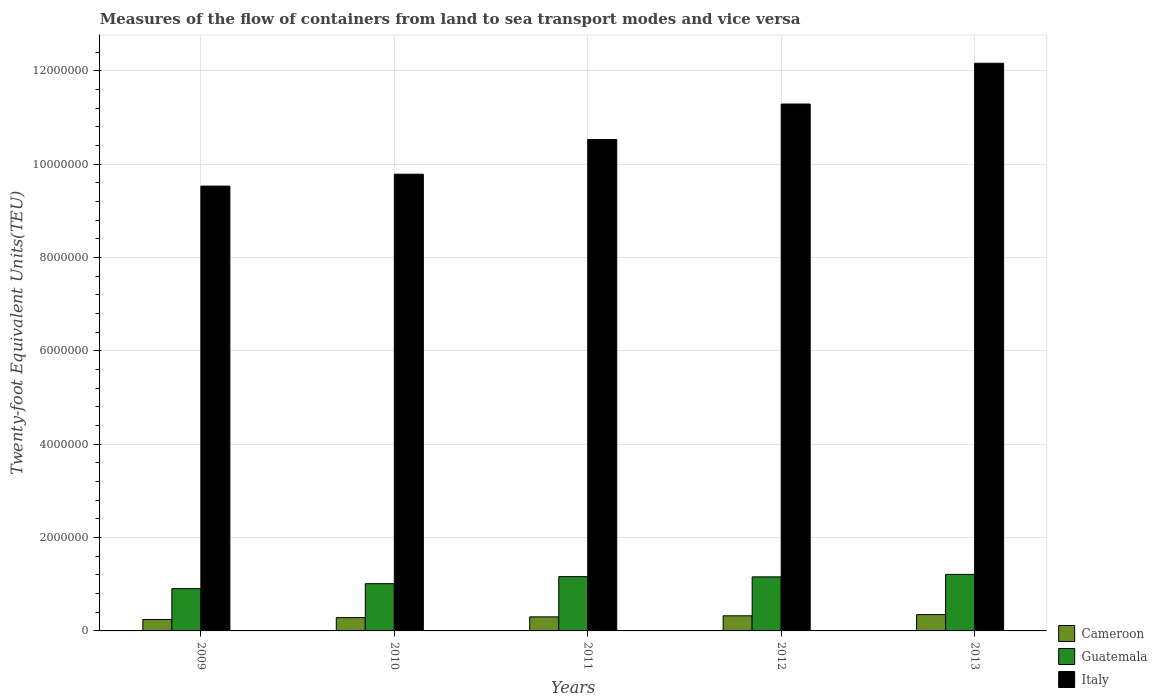How many groups of bars are there?
Make the answer very short. 5. How many bars are there on the 2nd tick from the right?
Give a very brief answer. 3. What is the label of the 1st group of bars from the left?
Offer a terse response. 2009. What is the container port traffic in Cameroon in 2013?
Your response must be concise. 3.50e+05. Across all years, what is the maximum container port traffic in Italy?
Provide a short and direct response. 1.22e+07. Across all years, what is the minimum container port traffic in Italy?
Provide a short and direct response. 9.53e+06. What is the total container port traffic in Guatemala in the graph?
Offer a terse response. 5.45e+06. What is the difference between the container port traffic in Cameroon in 2009 and that in 2010?
Provide a succinct answer. -3.95e+04. What is the difference between the container port traffic in Cameroon in 2009 and the container port traffic in Italy in 2012?
Make the answer very short. -1.10e+07. What is the average container port traffic in Cameroon per year?
Provide a succinct answer. 3.01e+05. In the year 2012, what is the difference between the container port traffic in Italy and container port traffic in Cameroon?
Keep it short and to the point. 1.10e+07. In how many years, is the container port traffic in Cameroon greater than 10800000 TEU?
Your answer should be very brief. 0. What is the ratio of the container port traffic in Italy in 2009 to that in 2013?
Keep it short and to the point. 0.78. Is the container port traffic in Cameroon in 2009 less than that in 2012?
Offer a terse response. Yes. Is the difference between the container port traffic in Italy in 2010 and 2012 greater than the difference between the container port traffic in Cameroon in 2010 and 2012?
Your answer should be compact. No. What is the difference between the highest and the second highest container port traffic in Cameroon?
Your response must be concise. 2.56e+04. What is the difference between the highest and the lowest container port traffic in Italy?
Keep it short and to the point. 2.63e+06. Is the sum of the container port traffic in Cameroon in 2010 and 2012 greater than the maximum container port traffic in Italy across all years?
Your response must be concise. No. What does the 2nd bar from the left in 2010 represents?
Ensure brevity in your answer.  Guatemala. What does the 2nd bar from the right in 2013 represents?
Keep it short and to the point. Guatemala. Are all the bars in the graph horizontal?
Make the answer very short. No. How many years are there in the graph?
Offer a terse response. 5. Does the graph contain any zero values?
Your answer should be very brief. No. Does the graph contain grids?
Offer a terse response. Yes. What is the title of the graph?
Provide a succinct answer. Measures of the flow of containers from land to sea transport modes and vice versa. Does "Gabon" appear as one of the legend labels in the graph?
Offer a very short reply. No. What is the label or title of the Y-axis?
Provide a succinct answer. Twenty-foot Equivalent Units(TEU). What is the Twenty-foot Equivalent Units(TEU) of Cameroon in 2009?
Offer a very short reply. 2.46e+05. What is the Twenty-foot Equivalent Units(TEU) of Guatemala in 2009?
Offer a terse response. 9.06e+05. What is the Twenty-foot Equivalent Units(TEU) in Italy in 2009?
Make the answer very short. 9.53e+06. What is the Twenty-foot Equivalent Units(TEU) in Cameroon in 2010?
Offer a terse response. 2.85e+05. What is the Twenty-foot Equivalent Units(TEU) in Guatemala in 2010?
Ensure brevity in your answer.  1.01e+06. What is the Twenty-foot Equivalent Units(TEU) of Italy in 2010?
Make the answer very short. 9.79e+06. What is the Twenty-foot Equivalent Units(TEU) in Cameroon in 2011?
Offer a terse response. 3.01e+05. What is the Twenty-foot Equivalent Units(TEU) in Guatemala in 2011?
Provide a short and direct response. 1.16e+06. What is the Twenty-foot Equivalent Units(TEU) in Italy in 2011?
Give a very brief answer. 1.05e+07. What is the Twenty-foot Equivalent Units(TEU) of Cameroon in 2012?
Ensure brevity in your answer.  3.24e+05. What is the Twenty-foot Equivalent Units(TEU) in Guatemala in 2012?
Provide a succinct answer. 1.16e+06. What is the Twenty-foot Equivalent Units(TEU) in Italy in 2012?
Ensure brevity in your answer.  1.13e+07. What is the Twenty-foot Equivalent Units(TEU) in Cameroon in 2013?
Your answer should be very brief. 3.50e+05. What is the Twenty-foot Equivalent Units(TEU) in Guatemala in 2013?
Your response must be concise. 1.21e+06. What is the Twenty-foot Equivalent Units(TEU) of Italy in 2013?
Keep it short and to the point. 1.22e+07. Across all years, what is the maximum Twenty-foot Equivalent Units(TEU) in Cameroon?
Give a very brief answer. 3.50e+05. Across all years, what is the maximum Twenty-foot Equivalent Units(TEU) of Guatemala?
Provide a succinct answer. 1.21e+06. Across all years, what is the maximum Twenty-foot Equivalent Units(TEU) of Italy?
Ensure brevity in your answer.  1.22e+07. Across all years, what is the minimum Twenty-foot Equivalent Units(TEU) of Cameroon?
Provide a short and direct response. 2.46e+05. Across all years, what is the minimum Twenty-foot Equivalent Units(TEU) in Guatemala?
Keep it short and to the point. 9.06e+05. Across all years, what is the minimum Twenty-foot Equivalent Units(TEU) in Italy?
Ensure brevity in your answer.  9.53e+06. What is the total Twenty-foot Equivalent Units(TEU) in Cameroon in the graph?
Offer a terse response. 1.51e+06. What is the total Twenty-foot Equivalent Units(TEU) in Guatemala in the graph?
Provide a short and direct response. 5.45e+06. What is the total Twenty-foot Equivalent Units(TEU) in Italy in the graph?
Provide a succinct answer. 5.33e+07. What is the difference between the Twenty-foot Equivalent Units(TEU) in Cameroon in 2009 and that in 2010?
Ensure brevity in your answer.  -3.95e+04. What is the difference between the Twenty-foot Equivalent Units(TEU) of Guatemala in 2009 and that in 2010?
Ensure brevity in your answer.  -1.06e+05. What is the difference between the Twenty-foot Equivalent Units(TEU) of Italy in 2009 and that in 2010?
Give a very brief answer. -2.55e+05. What is the difference between the Twenty-foot Equivalent Units(TEU) of Cameroon in 2009 and that in 2011?
Provide a succinct answer. -5.58e+04. What is the difference between the Twenty-foot Equivalent Units(TEU) of Guatemala in 2009 and that in 2011?
Provide a short and direct response. -2.57e+05. What is the difference between the Twenty-foot Equivalent Units(TEU) of Italy in 2009 and that in 2011?
Provide a short and direct response. -9.99e+05. What is the difference between the Twenty-foot Equivalent Units(TEU) in Cameroon in 2009 and that in 2012?
Your response must be concise. -7.84e+04. What is the difference between the Twenty-foot Equivalent Units(TEU) in Guatemala in 2009 and that in 2012?
Your answer should be compact. -2.52e+05. What is the difference between the Twenty-foot Equivalent Units(TEU) of Italy in 2009 and that in 2012?
Ensure brevity in your answer.  -1.76e+06. What is the difference between the Twenty-foot Equivalent Units(TEU) of Cameroon in 2009 and that in 2013?
Offer a very short reply. -1.04e+05. What is the difference between the Twenty-foot Equivalent Units(TEU) of Guatemala in 2009 and that in 2013?
Ensure brevity in your answer.  -3.05e+05. What is the difference between the Twenty-foot Equivalent Units(TEU) in Italy in 2009 and that in 2013?
Provide a short and direct response. -2.63e+06. What is the difference between the Twenty-foot Equivalent Units(TEU) of Cameroon in 2010 and that in 2011?
Offer a very short reply. -1.62e+04. What is the difference between the Twenty-foot Equivalent Units(TEU) of Guatemala in 2010 and that in 2011?
Provide a short and direct response. -1.51e+05. What is the difference between the Twenty-foot Equivalent Units(TEU) of Italy in 2010 and that in 2011?
Make the answer very short. -7.44e+05. What is the difference between the Twenty-foot Equivalent Units(TEU) of Cameroon in 2010 and that in 2012?
Your answer should be compact. -3.88e+04. What is the difference between the Twenty-foot Equivalent Units(TEU) of Guatemala in 2010 and that in 2012?
Ensure brevity in your answer.  -1.46e+05. What is the difference between the Twenty-foot Equivalent Units(TEU) in Italy in 2010 and that in 2012?
Ensure brevity in your answer.  -1.50e+06. What is the difference between the Twenty-foot Equivalent Units(TEU) of Cameroon in 2010 and that in 2013?
Ensure brevity in your answer.  -6.44e+04. What is the difference between the Twenty-foot Equivalent Units(TEU) in Guatemala in 2010 and that in 2013?
Make the answer very short. -1.99e+05. What is the difference between the Twenty-foot Equivalent Units(TEU) of Italy in 2010 and that in 2013?
Offer a terse response. -2.38e+06. What is the difference between the Twenty-foot Equivalent Units(TEU) of Cameroon in 2011 and that in 2012?
Provide a succinct answer. -2.26e+04. What is the difference between the Twenty-foot Equivalent Units(TEU) of Guatemala in 2011 and that in 2012?
Provide a short and direct response. 4700. What is the difference between the Twenty-foot Equivalent Units(TEU) in Italy in 2011 and that in 2012?
Give a very brief answer. -7.60e+05. What is the difference between the Twenty-foot Equivalent Units(TEU) in Cameroon in 2011 and that in 2013?
Your answer should be very brief. -4.82e+04. What is the difference between the Twenty-foot Equivalent Units(TEU) of Guatemala in 2011 and that in 2013?
Your response must be concise. -4.85e+04. What is the difference between the Twenty-foot Equivalent Units(TEU) in Italy in 2011 and that in 2013?
Offer a very short reply. -1.63e+06. What is the difference between the Twenty-foot Equivalent Units(TEU) of Cameroon in 2012 and that in 2013?
Make the answer very short. -2.56e+04. What is the difference between the Twenty-foot Equivalent Units(TEU) of Guatemala in 2012 and that in 2013?
Offer a terse response. -5.32e+04. What is the difference between the Twenty-foot Equivalent Units(TEU) of Italy in 2012 and that in 2013?
Your answer should be compact. -8.74e+05. What is the difference between the Twenty-foot Equivalent Units(TEU) in Cameroon in 2009 and the Twenty-foot Equivalent Units(TEU) in Guatemala in 2010?
Offer a very short reply. -7.67e+05. What is the difference between the Twenty-foot Equivalent Units(TEU) in Cameroon in 2009 and the Twenty-foot Equivalent Units(TEU) in Italy in 2010?
Your answer should be compact. -9.54e+06. What is the difference between the Twenty-foot Equivalent Units(TEU) in Guatemala in 2009 and the Twenty-foot Equivalent Units(TEU) in Italy in 2010?
Your answer should be very brief. -8.88e+06. What is the difference between the Twenty-foot Equivalent Units(TEU) of Cameroon in 2009 and the Twenty-foot Equivalent Units(TEU) of Guatemala in 2011?
Offer a very short reply. -9.18e+05. What is the difference between the Twenty-foot Equivalent Units(TEU) in Cameroon in 2009 and the Twenty-foot Equivalent Units(TEU) in Italy in 2011?
Provide a succinct answer. -1.03e+07. What is the difference between the Twenty-foot Equivalent Units(TEU) in Guatemala in 2009 and the Twenty-foot Equivalent Units(TEU) in Italy in 2011?
Offer a very short reply. -9.63e+06. What is the difference between the Twenty-foot Equivalent Units(TEU) in Cameroon in 2009 and the Twenty-foot Equivalent Units(TEU) in Guatemala in 2012?
Offer a very short reply. -9.13e+05. What is the difference between the Twenty-foot Equivalent Units(TEU) in Cameroon in 2009 and the Twenty-foot Equivalent Units(TEU) in Italy in 2012?
Your answer should be very brief. -1.10e+07. What is the difference between the Twenty-foot Equivalent Units(TEU) in Guatemala in 2009 and the Twenty-foot Equivalent Units(TEU) in Italy in 2012?
Ensure brevity in your answer.  -1.04e+07. What is the difference between the Twenty-foot Equivalent Units(TEU) of Cameroon in 2009 and the Twenty-foot Equivalent Units(TEU) of Guatemala in 2013?
Ensure brevity in your answer.  -9.66e+05. What is the difference between the Twenty-foot Equivalent Units(TEU) of Cameroon in 2009 and the Twenty-foot Equivalent Units(TEU) of Italy in 2013?
Your response must be concise. -1.19e+07. What is the difference between the Twenty-foot Equivalent Units(TEU) in Guatemala in 2009 and the Twenty-foot Equivalent Units(TEU) in Italy in 2013?
Keep it short and to the point. -1.13e+07. What is the difference between the Twenty-foot Equivalent Units(TEU) in Cameroon in 2010 and the Twenty-foot Equivalent Units(TEU) in Guatemala in 2011?
Your response must be concise. -8.78e+05. What is the difference between the Twenty-foot Equivalent Units(TEU) in Cameroon in 2010 and the Twenty-foot Equivalent Units(TEU) in Italy in 2011?
Give a very brief answer. -1.02e+07. What is the difference between the Twenty-foot Equivalent Units(TEU) of Guatemala in 2010 and the Twenty-foot Equivalent Units(TEU) of Italy in 2011?
Provide a short and direct response. -9.52e+06. What is the difference between the Twenty-foot Equivalent Units(TEU) of Cameroon in 2010 and the Twenty-foot Equivalent Units(TEU) of Guatemala in 2012?
Ensure brevity in your answer.  -8.73e+05. What is the difference between the Twenty-foot Equivalent Units(TEU) in Cameroon in 2010 and the Twenty-foot Equivalent Units(TEU) in Italy in 2012?
Give a very brief answer. -1.10e+07. What is the difference between the Twenty-foot Equivalent Units(TEU) of Guatemala in 2010 and the Twenty-foot Equivalent Units(TEU) of Italy in 2012?
Your answer should be very brief. -1.03e+07. What is the difference between the Twenty-foot Equivalent Units(TEU) of Cameroon in 2010 and the Twenty-foot Equivalent Units(TEU) of Guatemala in 2013?
Your response must be concise. -9.27e+05. What is the difference between the Twenty-foot Equivalent Units(TEU) in Cameroon in 2010 and the Twenty-foot Equivalent Units(TEU) in Italy in 2013?
Keep it short and to the point. -1.19e+07. What is the difference between the Twenty-foot Equivalent Units(TEU) of Guatemala in 2010 and the Twenty-foot Equivalent Units(TEU) of Italy in 2013?
Keep it short and to the point. -1.12e+07. What is the difference between the Twenty-foot Equivalent Units(TEU) of Cameroon in 2011 and the Twenty-foot Equivalent Units(TEU) of Guatemala in 2012?
Ensure brevity in your answer.  -8.57e+05. What is the difference between the Twenty-foot Equivalent Units(TEU) in Cameroon in 2011 and the Twenty-foot Equivalent Units(TEU) in Italy in 2012?
Your answer should be compact. -1.10e+07. What is the difference between the Twenty-foot Equivalent Units(TEU) of Guatemala in 2011 and the Twenty-foot Equivalent Units(TEU) of Italy in 2012?
Provide a succinct answer. -1.01e+07. What is the difference between the Twenty-foot Equivalent Units(TEU) of Cameroon in 2011 and the Twenty-foot Equivalent Units(TEU) of Guatemala in 2013?
Keep it short and to the point. -9.10e+05. What is the difference between the Twenty-foot Equivalent Units(TEU) in Cameroon in 2011 and the Twenty-foot Equivalent Units(TEU) in Italy in 2013?
Ensure brevity in your answer.  -1.19e+07. What is the difference between the Twenty-foot Equivalent Units(TEU) in Guatemala in 2011 and the Twenty-foot Equivalent Units(TEU) in Italy in 2013?
Give a very brief answer. -1.10e+07. What is the difference between the Twenty-foot Equivalent Units(TEU) of Cameroon in 2012 and the Twenty-foot Equivalent Units(TEU) of Guatemala in 2013?
Your response must be concise. -8.88e+05. What is the difference between the Twenty-foot Equivalent Units(TEU) of Cameroon in 2012 and the Twenty-foot Equivalent Units(TEU) of Italy in 2013?
Your answer should be compact. -1.18e+07. What is the difference between the Twenty-foot Equivalent Units(TEU) in Guatemala in 2012 and the Twenty-foot Equivalent Units(TEU) in Italy in 2013?
Your response must be concise. -1.10e+07. What is the average Twenty-foot Equivalent Units(TEU) in Cameroon per year?
Provide a succinct answer. 3.01e+05. What is the average Twenty-foot Equivalent Units(TEU) in Guatemala per year?
Give a very brief answer. 1.09e+06. What is the average Twenty-foot Equivalent Units(TEU) in Italy per year?
Provide a succinct answer. 1.07e+07. In the year 2009, what is the difference between the Twenty-foot Equivalent Units(TEU) of Cameroon and Twenty-foot Equivalent Units(TEU) of Guatemala?
Keep it short and to the point. -6.61e+05. In the year 2009, what is the difference between the Twenty-foot Equivalent Units(TEU) in Cameroon and Twenty-foot Equivalent Units(TEU) in Italy?
Offer a terse response. -9.29e+06. In the year 2009, what is the difference between the Twenty-foot Equivalent Units(TEU) of Guatemala and Twenty-foot Equivalent Units(TEU) of Italy?
Offer a very short reply. -8.63e+06. In the year 2010, what is the difference between the Twenty-foot Equivalent Units(TEU) of Cameroon and Twenty-foot Equivalent Units(TEU) of Guatemala?
Offer a very short reply. -7.27e+05. In the year 2010, what is the difference between the Twenty-foot Equivalent Units(TEU) of Cameroon and Twenty-foot Equivalent Units(TEU) of Italy?
Ensure brevity in your answer.  -9.50e+06. In the year 2010, what is the difference between the Twenty-foot Equivalent Units(TEU) of Guatemala and Twenty-foot Equivalent Units(TEU) of Italy?
Ensure brevity in your answer.  -8.78e+06. In the year 2011, what is the difference between the Twenty-foot Equivalent Units(TEU) in Cameroon and Twenty-foot Equivalent Units(TEU) in Guatemala?
Offer a terse response. -8.62e+05. In the year 2011, what is the difference between the Twenty-foot Equivalent Units(TEU) of Cameroon and Twenty-foot Equivalent Units(TEU) of Italy?
Your answer should be very brief. -1.02e+07. In the year 2011, what is the difference between the Twenty-foot Equivalent Units(TEU) of Guatemala and Twenty-foot Equivalent Units(TEU) of Italy?
Provide a short and direct response. -9.37e+06. In the year 2012, what is the difference between the Twenty-foot Equivalent Units(TEU) in Cameroon and Twenty-foot Equivalent Units(TEU) in Guatemala?
Offer a terse response. -8.34e+05. In the year 2012, what is the difference between the Twenty-foot Equivalent Units(TEU) of Cameroon and Twenty-foot Equivalent Units(TEU) of Italy?
Your response must be concise. -1.10e+07. In the year 2012, what is the difference between the Twenty-foot Equivalent Units(TEU) of Guatemala and Twenty-foot Equivalent Units(TEU) of Italy?
Your response must be concise. -1.01e+07. In the year 2013, what is the difference between the Twenty-foot Equivalent Units(TEU) in Cameroon and Twenty-foot Equivalent Units(TEU) in Guatemala?
Your answer should be compact. -8.62e+05. In the year 2013, what is the difference between the Twenty-foot Equivalent Units(TEU) of Cameroon and Twenty-foot Equivalent Units(TEU) of Italy?
Offer a terse response. -1.18e+07. In the year 2013, what is the difference between the Twenty-foot Equivalent Units(TEU) in Guatemala and Twenty-foot Equivalent Units(TEU) in Italy?
Your answer should be very brief. -1.10e+07. What is the ratio of the Twenty-foot Equivalent Units(TEU) of Cameroon in 2009 to that in 2010?
Keep it short and to the point. 0.86. What is the ratio of the Twenty-foot Equivalent Units(TEU) in Guatemala in 2009 to that in 2010?
Ensure brevity in your answer.  0.9. What is the ratio of the Twenty-foot Equivalent Units(TEU) of Cameroon in 2009 to that in 2011?
Offer a very short reply. 0.81. What is the ratio of the Twenty-foot Equivalent Units(TEU) of Guatemala in 2009 to that in 2011?
Offer a terse response. 0.78. What is the ratio of the Twenty-foot Equivalent Units(TEU) of Italy in 2009 to that in 2011?
Your answer should be very brief. 0.91. What is the ratio of the Twenty-foot Equivalent Units(TEU) of Cameroon in 2009 to that in 2012?
Keep it short and to the point. 0.76. What is the ratio of the Twenty-foot Equivalent Units(TEU) of Guatemala in 2009 to that in 2012?
Give a very brief answer. 0.78. What is the ratio of the Twenty-foot Equivalent Units(TEU) in Italy in 2009 to that in 2012?
Give a very brief answer. 0.84. What is the ratio of the Twenty-foot Equivalent Units(TEU) in Cameroon in 2009 to that in 2013?
Offer a terse response. 0.7. What is the ratio of the Twenty-foot Equivalent Units(TEU) in Guatemala in 2009 to that in 2013?
Give a very brief answer. 0.75. What is the ratio of the Twenty-foot Equivalent Units(TEU) of Italy in 2009 to that in 2013?
Keep it short and to the point. 0.78. What is the ratio of the Twenty-foot Equivalent Units(TEU) of Cameroon in 2010 to that in 2011?
Ensure brevity in your answer.  0.95. What is the ratio of the Twenty-foot Equivalent Units(TEU) of Guatemala in 2010 to that in 2011?
Keep it short and to the point. 0.87. What is the ratio of the Twenty-foot Equivalent Units(TEU) in Italy in 2010 to that in 2011?
Offer a very short reply. 0.93. What is the ratio of the Twenty-foot Equivalent Units(TEU) of Cameroon in 2010 to that in 2012?
Ensure brevity in your answer.  0.88. What is the ratio of the Twenty-foot Equivalent Units(TEU) of Guatemala in 2010 to that in 2012?
Your response must be concise. 0.87. What is the ratio of the Twenty-foot Equivalent Units(TEU) of Italy in 2010 to that in 2012?
Keep it short and to the point. 0.87. What is the ratio of the Twenty-foot Equivalent Units(TEU) of Cameroon in 2010 to that in 2013?
Your response must be concise. 0.82. What is the ratio of the Twenty-foot Equivalent Units(TEU) of Guatemala in 2010 to that in 2013?
Offer a very short reply. 0.84. What is the ratio of the Twenty-foot Equivalent Units(TEU) in Italy in 2010 to that in 2013?
Keep it short and to the point. 0.8. What is the ratio of the Twenty-foot Equivalent Units(TEU) of Cameroon in 2011 to that in 2012?
Make the answer very short. 0.93. What is the ratio of the Twenty-foot Equivalent Units(TEU) in Guatemala in 2011 to that in 2012?
Provide a succinct answer. 1. What is the ratio of the Twenty-foot Equivalent Units(TEU) in Italy in 2011 to that in 2012?
Make the answer very short. 0.93. What is the ratio of the Twenty-foot Equivalent Units(TEU) in Cameroon in 2011 to that in 2013?
Ensure brevity in your answer.  0.86. What is the ratio of the Twenty-foot Equivalent Units(TEU) of Italy in 2011 to that in 2013?
Your answer should be compact. 0.87. What is the ratio of the Twenty-foot Equivalent Units(TEU) of Cameroon in 2012 to that in 2013?
Your response must be concise. 0.93. What is the ratio of the Twenty-foot Equivalent Units(TEU) in Guatemala in 2012 to that in 2013?
Provide a succinct answer. 0.96. What is the ratio of the Twenty-foot Equivalent Units(TEU) of Italy in 2012 to that in 2013?
Offer a terse response. 0.93. What is the difference between the highest and the second highest Twenty-foot Equivalent Units(TEU) of Cameroon?
Your answer should be very brief. 2.56e+04. What is the difference between the highest and the second highest Twenty-foot Equivalent Units(TEU) in Guatemala?
Make the answer very short. 4.85e+04. What is the difference between the highest and the second highest Twenty-foot Equivalent Units(TEU) in Italy?
Provide a succinct answer. 8.74e+05. What is the difference between the highest and the lowest Twenty-foot Equivalent Units(TEU) of Cameroon?
Ensure brevity in your answer.  1.04e+05. What is the difference between the highest and the lowest Twenty-foot Equivalent Units(TEU) of Guatemala?
Offer a very short reply. 3.05e+05. What is the difference between the highest and the lowest Twenty-foot Equivalent Units(TEU) in Italy?
Ensure brevity in your answer.  2.63e+06. 